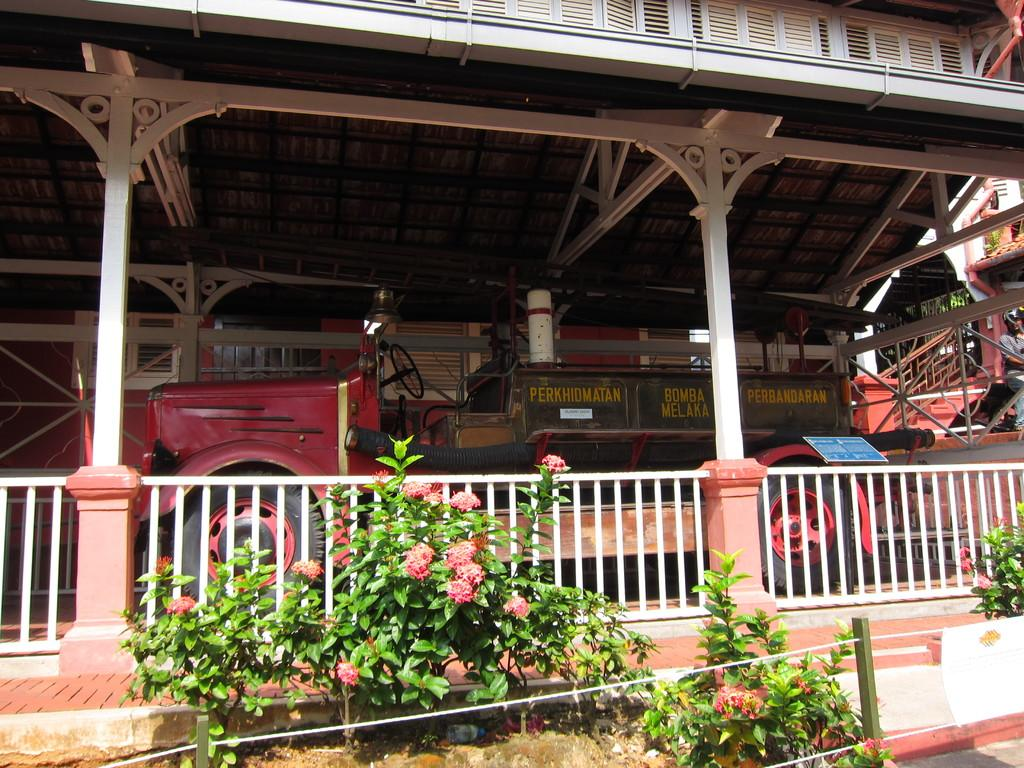What type of structure is visible in the image? There is a house in the image. What can be seen in front of the house? Plants are present in front of the house. What is inside the house? There is a vehicle inside the house. What color is the vehicle? The vehicle is red in color. What architectural feature is on the right side of the image? There are stairs on the right side of the image. Can you tell me how many babies are present in the image? There are no babies present in the image. What role does the actor play in the image? There is no actor present in the image. 